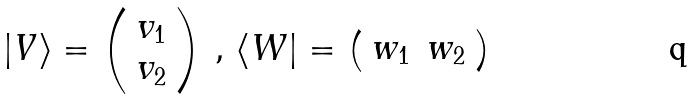Convert formula to latex. <formula><loc_0><loc_0><loc_500><loc_500>| V \rangle = \left ( \begin{array} { c } v _ { 1 } \\ v _ { 2 } \\ \end{array} \right ) \, , \, \langle W | = \left ( \begin{array} { c c } w _ { 1 } & w _ { 2 } \\ \end{array} \right )</formula> 